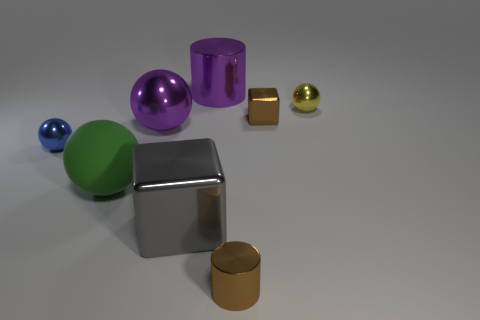What number of tiny brown rubber objects have the same shape as the green matte thing?
Ensure brevity in your answer.  0. What is the color of the other metallic ball that is the same size as the blue shiny ball?
Your response must be concise. Yellow. What is the color of the cylinder that is in front of the purple metal thing that is in front of the tiny sphere behind the small blue metallic ball?
Make the answer very short. Brown. Does the gray object have the same size as the metallic ball that is right of the small cylinder?
Ensure brevity in your answer.  No. What number of objects are either large brown metal balls or cylinders?
Your answer should be very brief. 2. Is there a tiny block that has the same material as the blue object?
Offer a very short reply. Yes. What is the size of the metal sphere that is the same color as the large cylinder?
Ensure brevity in your answer.  Large. There is a metallic cylinder right of the large purple thing on the right side of the large purple sphere; what color is it?
Ensure brevity in your answer.  Brown. Do the green rubber sphere and the blue metal object have the same size?
Your response must be concise. No. What number of cylinders are either green rubber objects or large things?
Offer a terse response. 1. 